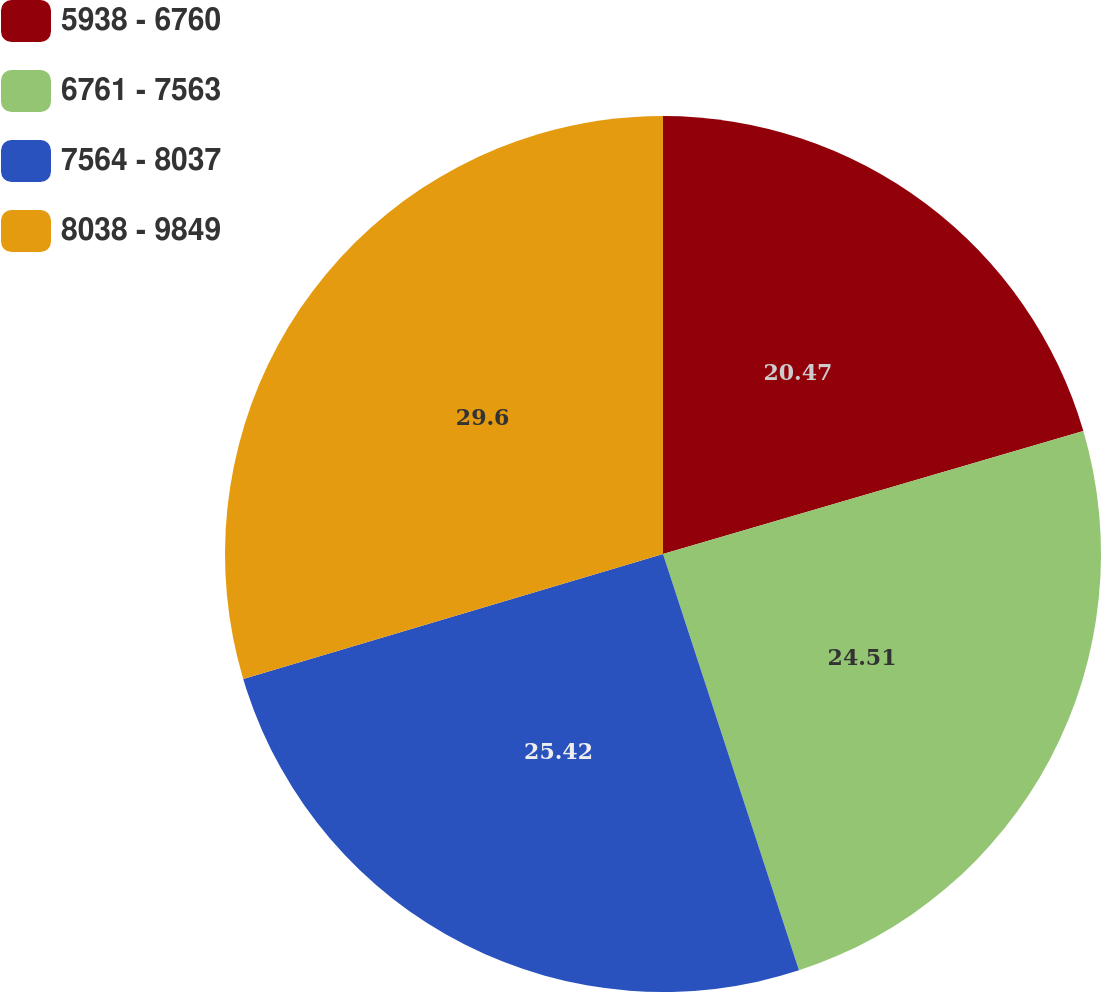Convert chart to OTSL. <chart><loc_0><loc_0><loc_500><loc_500><pie_chart><fcel>5938 - 6760<fcel>6761 - 7563<fcel>7564 - 8037<fcel>8038 - 9849<nl><fcel>20.47%<fcel>24.51%<fcel>25.42%<fcel>29.61%<nl></chart> 